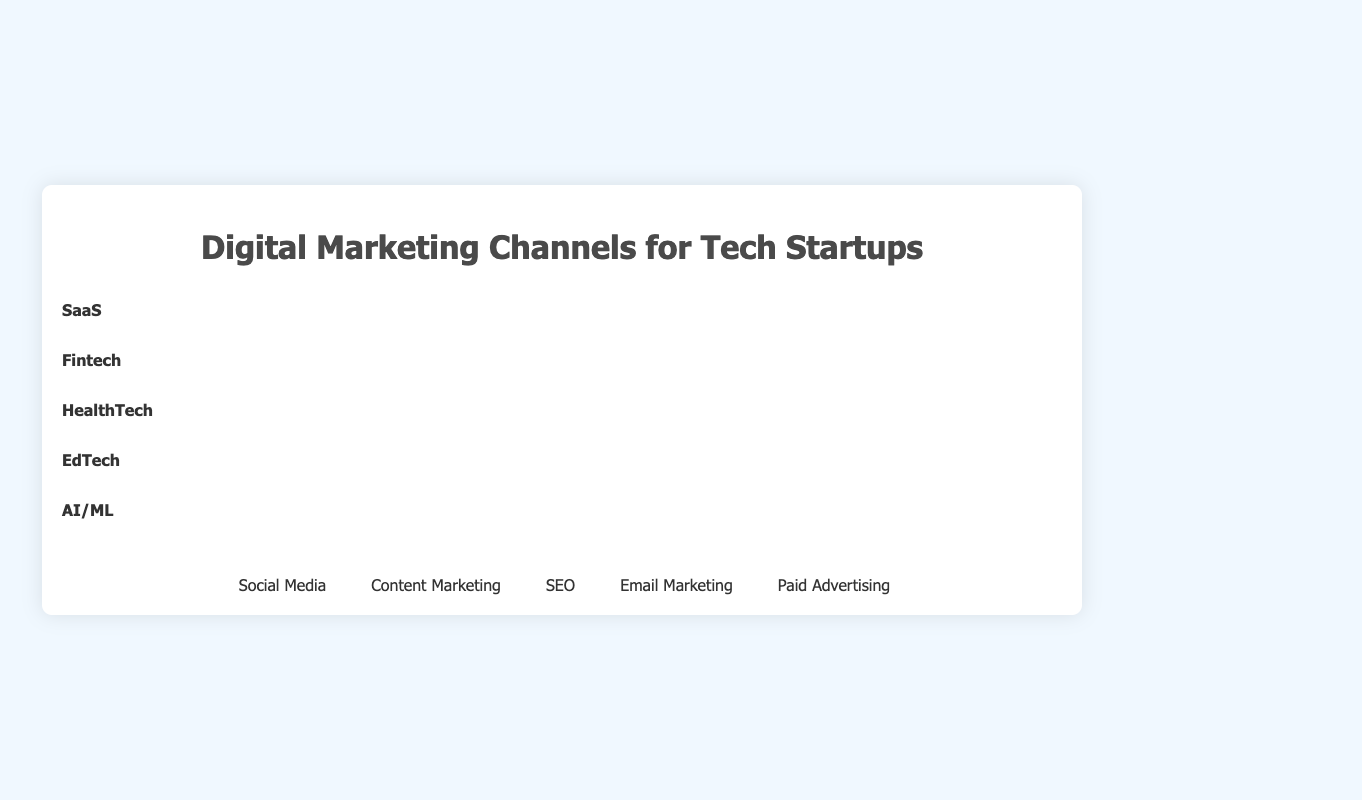Which industry uses "Social Media" the most? We look at the number of "Social Media" icons for each industry and see that EdTech has the most with 9 icons.
Answer: EdTech How many channels in total does "Fintech" use? For Fintech, we sum up the counts for all channels: Social Media (6) + Content Marketing (5) + SEO (7) + Email Marketing (4) + Paid Advertising (8), which adds up to 30.
Answer: 30 Which channel is most popular among "AI/ML" startups? For AI/ML, we compare the counts of each channel: Social Media (7), Content Marketing (9), SEO (8), Email Marketing (4), Paid Advertising (6). Content Marketing has the highest count.
Answer: Content Marketing Is the use of "SEO" more common in "EdTech" or "HealthTech"? Comparing the number of "SEO" icons, EdTech has 5 icons, while HealthTech has 6 icons.
Answer: HealthTech Among "Email Marketing" and "Paid Advertising", which channel has higher combined usage across all industries? We sum up the counts for each channel across all industries: Email Marketing: SaaS (5), Fintech (4), HealthTech (7), EdTech (6), AI/ML (4) which totals to 26. Paid Advertising: SaaS (4), Fintech (8), HealthTech (4), EdTech (3), AI/ML (6) which totals to 25.
Answer: Email Marketing Which industry has the lowest usage of "Paid Advertising"? We compare the counts for "Paid Advertising": SaaS (4), Fintech (8), HealthTech (4), EdTech (3), AI/ML (6). EdTech has the lowest with 3 icons.
Answer: EdTech What is the average number of channels used by "SaaS" startups? For SaaS, we sum up all counts: Social Media (8), Content Marketing (7), SEO (6), Email Marketing (5), Paid Advertising (4) which totals to 30. The average is 30/5 = 6.
Answer: 6 